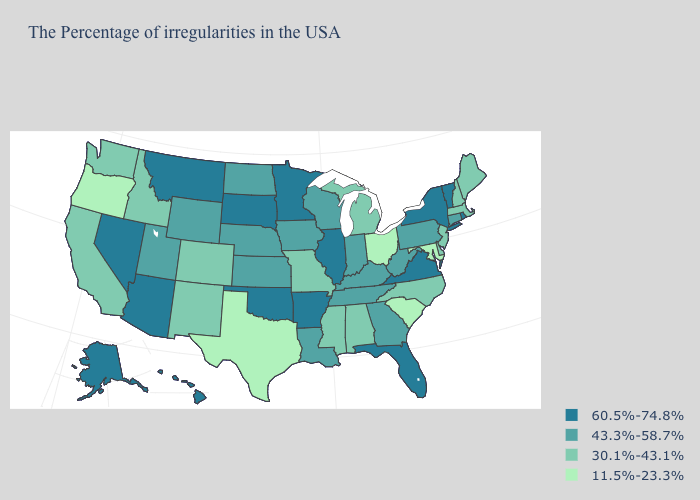How many symbols are there in the legend?
Short answer required. 4. Name the states that have a value in the range 30.1%-43.1%?
Quick response, please. Maine, Massachusetts, New Hampshire, New Jersey, Delaware, North Carolina, Michigan, Alabama, Mississippi, Missouri, Colorado, New Mexico, Idaho, California, Washington. What is the value of Wisconsin?
Give a very brief answer. 43.3%-58.7%. What is the lowest value in states that border Nebraska?
Give a very brief answer. 30.1%-43.1%. Which states have the highest value in the USA?
Answer briefly. Rhode Island, Vermont, New York, Virginia, Florida, Illinois, Arkansas, Minnesota, Oklahoma, South Dakota, Montana, Arizona, Nevada, Alaska, Hawaii. Does the first symbol in the legend represent the smallest category?
Keep it brief. No. What is the value of Ohio?
Write a very short answer. 11.5%-23.3%. Which states hav the highest value in the MidWest?
Concise answer only. Illinois, Minnesota, South Dakota. Which states have the lowest value in the USA?
Keep it brief. Maryland, South Carolina, Ohio, Texas, Oregon. Among the states that border Maine , which have the highest value?
Write a very short answer. New Hampshire. What is the highest value in the USA?
Give a very brief answer. 60.5%-74.8%. Does North Dakota have the same value as Colorado?
Answer briefly. No. Name the states that have a value in the range 60.5%-74.8%?
Write a very short answer. Rhode Island, Vermont, New York, Virginia, Florida, Illinois, Arkansas, Minnesota, Oklahoma, South Dakota, Montana, Arizona, Nevada, Alaska, Hawaii. What is the lowest value in the USA?
Short answer required. 11.5%-23.3%. Name the states that have a value in the range 43.3%-58.7%?
Quick response, please. Connecticut, Pennsylvania, West Virginia, Georgia, Kentucky, Indiana, Tennessee, Wisconsin, Louisiana, Iowa, Kansas, Nebraska, North Dakota, Wyoming, Utah. 